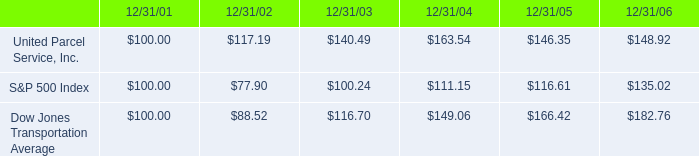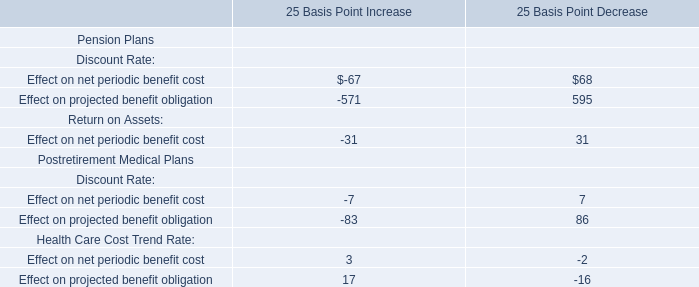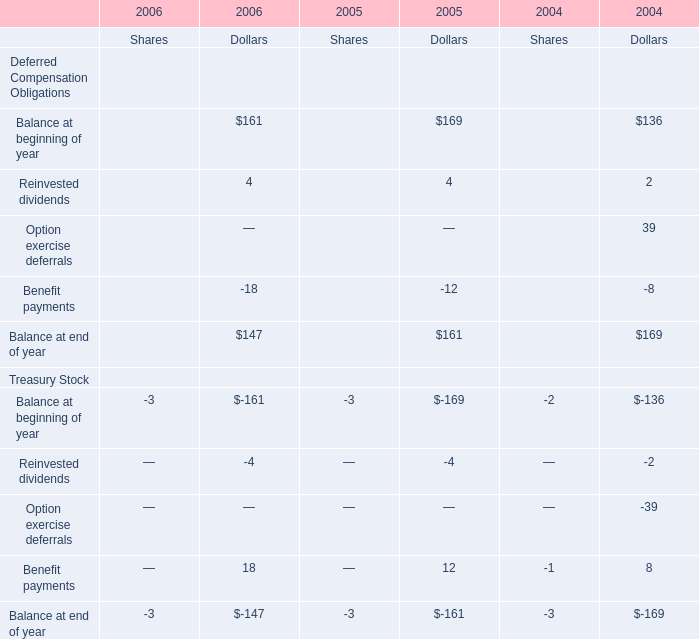What will Dollars for Balance at end of year for Deferred Compensation Obligations be like in 2007 if it develops with the same growth rate as in 2006? 
Computations: (147 * (1 + ((147 - 161) / 161)))
Answer: 134.21739. 